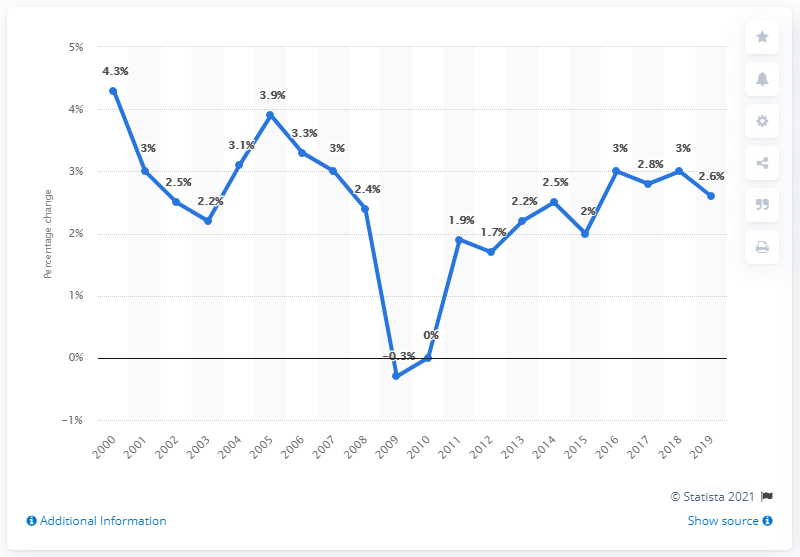Give some essential details in this illustration. The mode is 3. The price index for the year 2009 was negative, indicating that the general price level declined during that year. The Consumer Price Index for Housing improved by 2.6% between December 2018 and December 2019. 